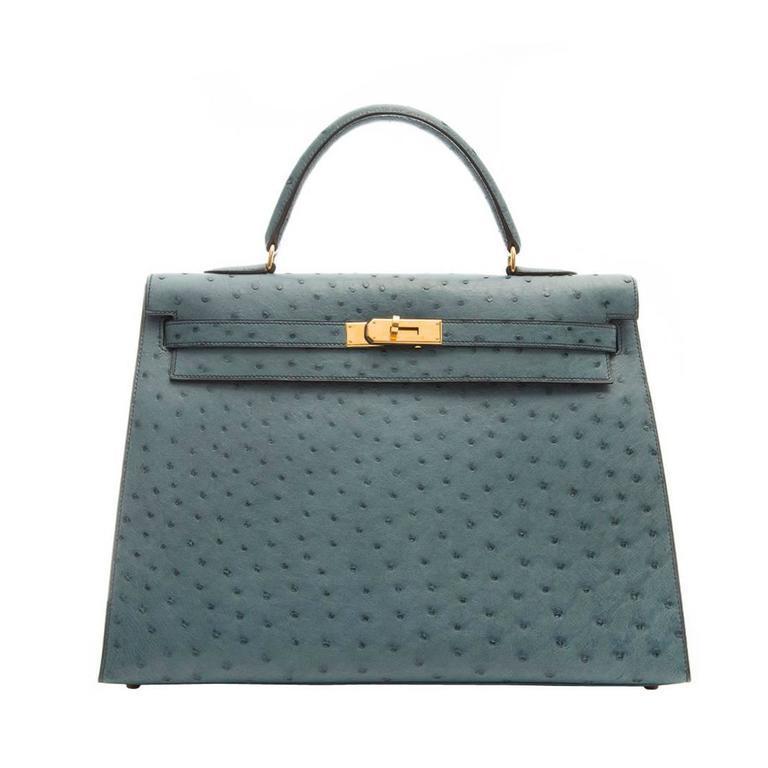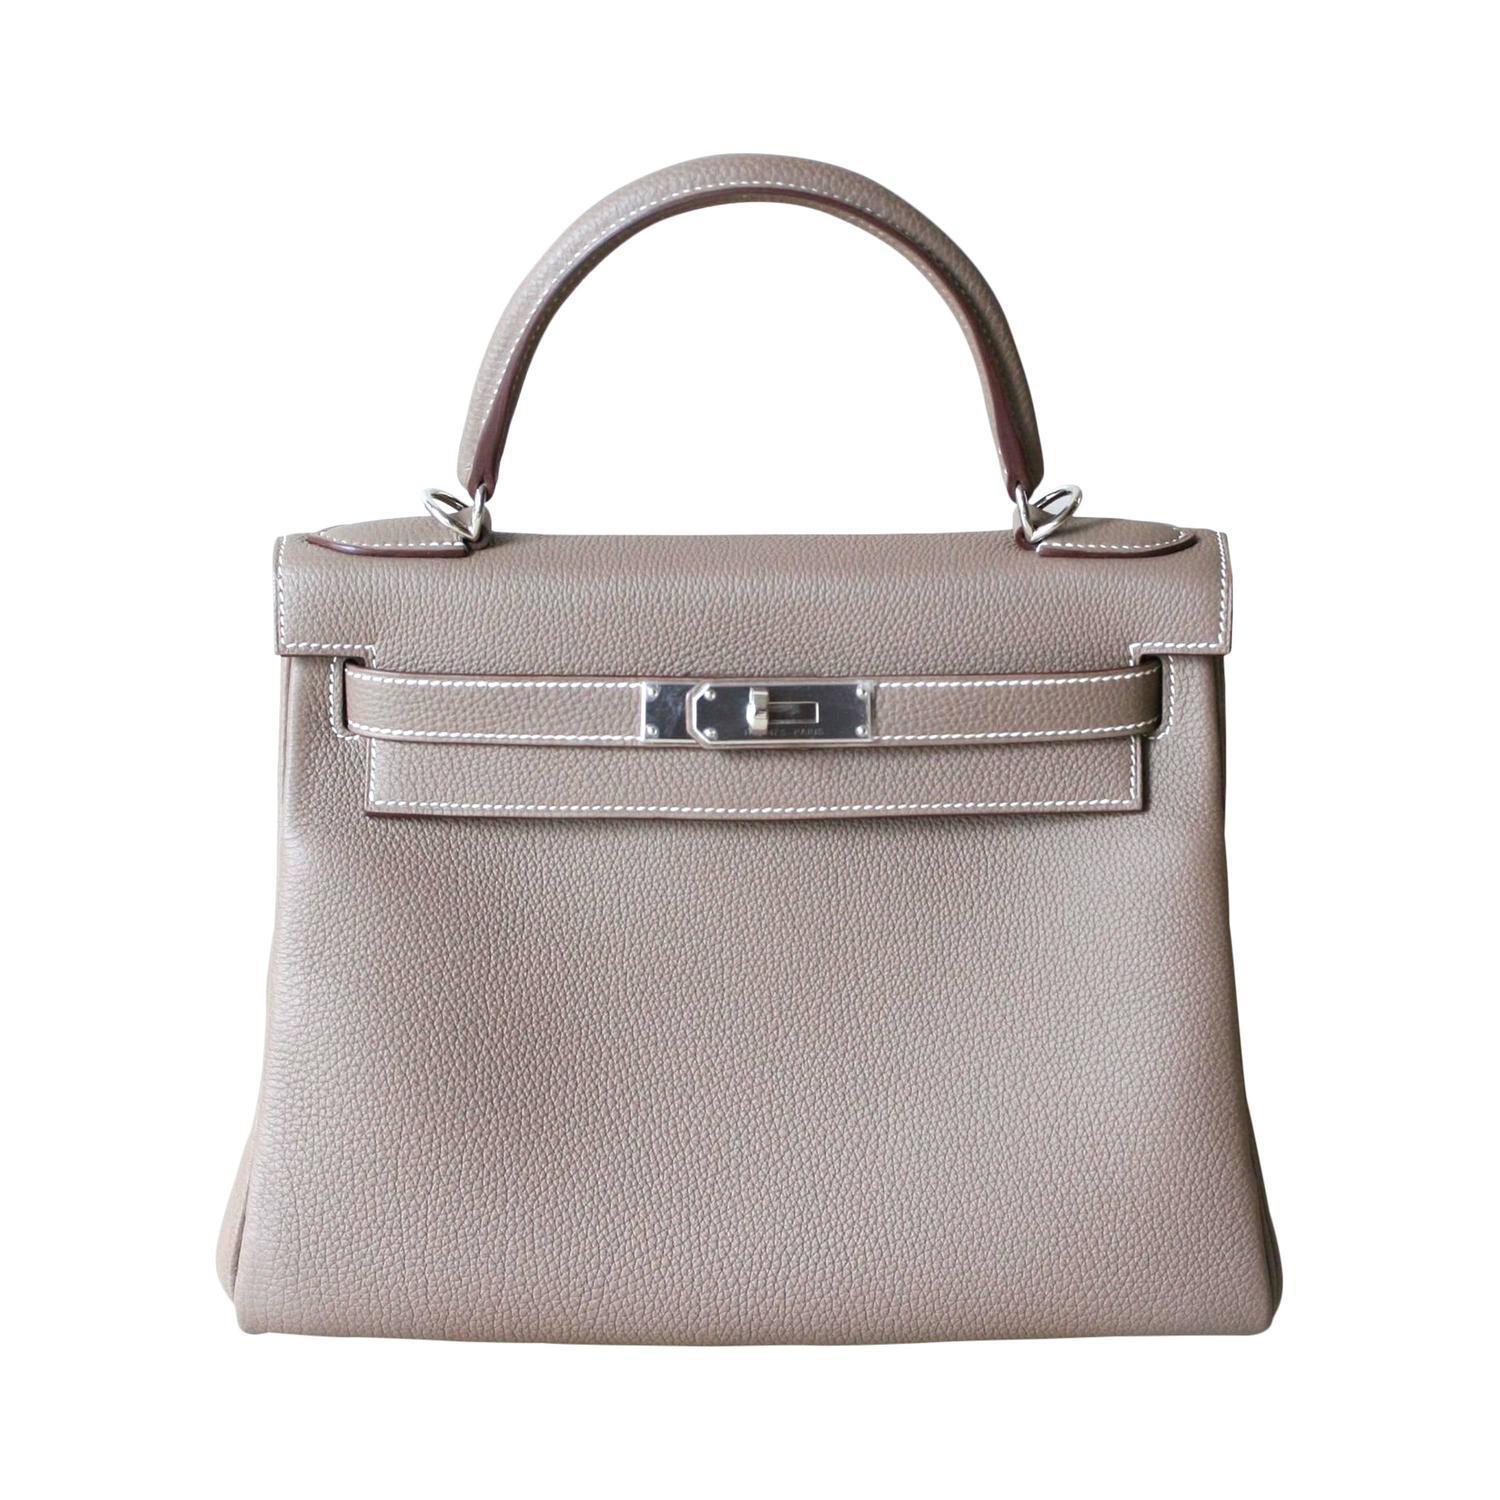The first image is the image on the left, the second image is the image on the right. For the images shown, is this caption "The purse in the left image is predominately blue." true? Answer yes or no. Yes. The first image is the image on the left, the second image is the image on the right. Analyze the images presented: Is the assertion "The bags in the left and right images are displayed in the same position." valid? Answer yes or no. Yes. 